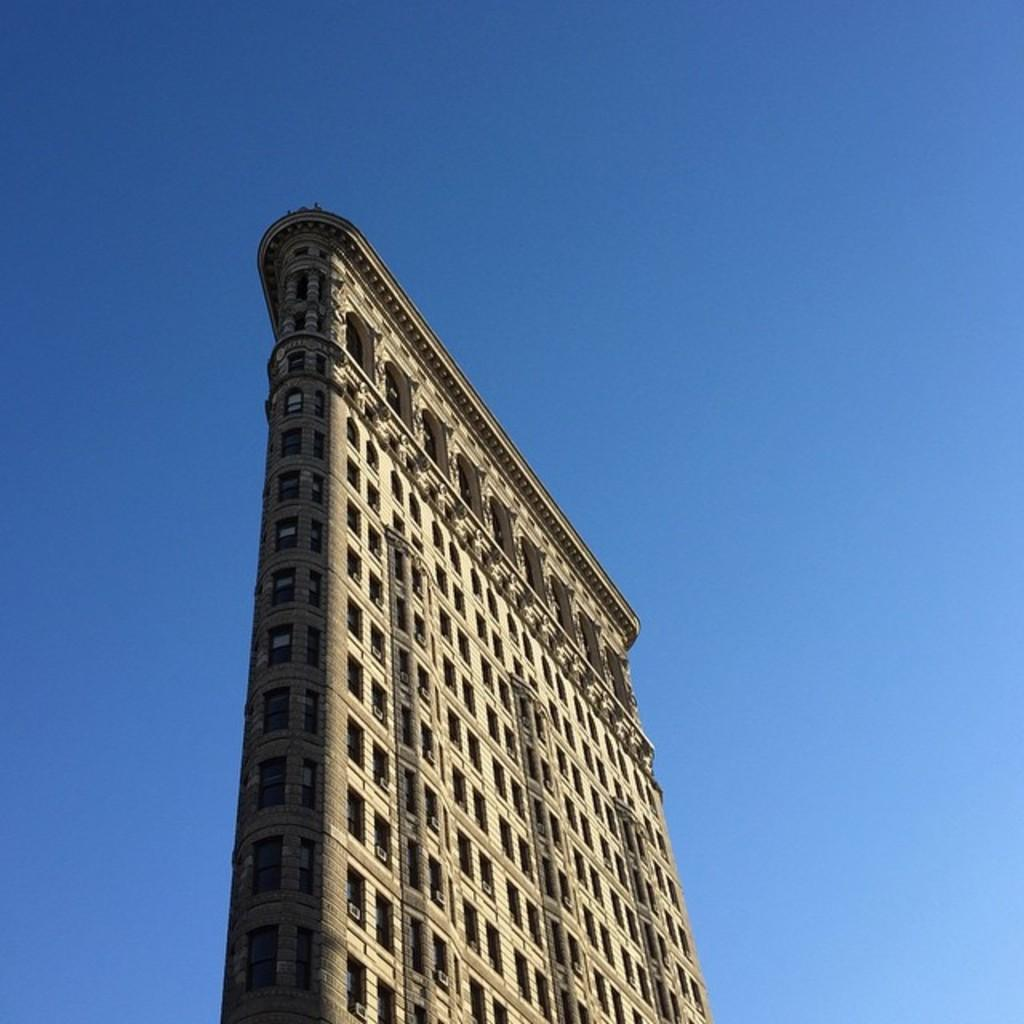What type of structure can be seen in the background of the image? There is a building in the background of the image. What else is visible in the background of the image? The sky is visible in the background of the image. How many books are hanging from the hook in the image? There is no hook or books present in the image. 